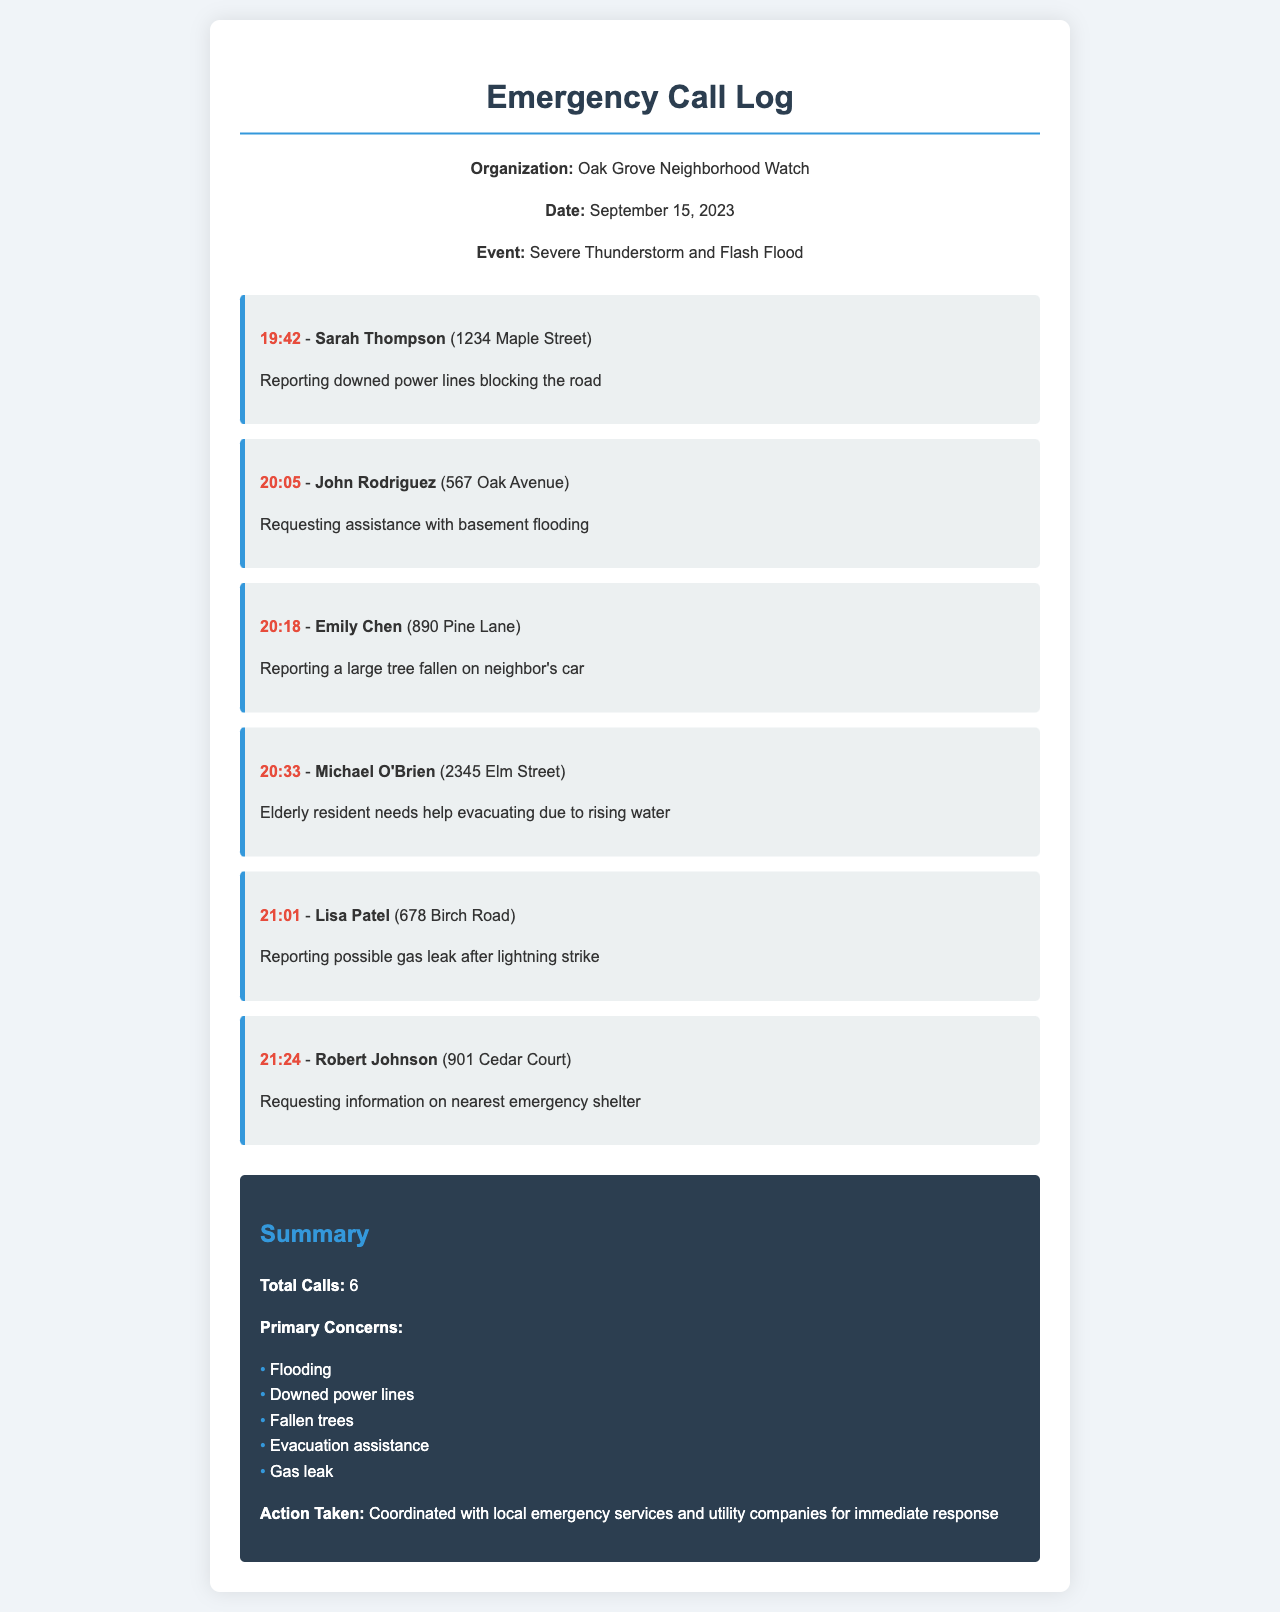What is the date of the event? The date of the event is explicitly stated in the document, which is September 15, 2023.
Answer: September 15, 2023 How many total calls were made? The total number of calls is provided in the summary section of the document, which lists the total calls as 6.
Answer: 6 Who reported the gas leak? The call log names Lisa Patel as the caller who reported a possible gas leak.
Answer: Lisa Patel What time did the first call occur? The time of the first call can be found in the call log, which lists it as 19:42.
Answer: 19:42 What was a primary concern during the storm? The summary section lists primary concerns, one of which is flooding.
Answer: Flooding Which caller requested evacuation assistance? The call log specifies that Michael O'Brien requested help evacuating due to rising water.
Answer: Michael O'Brien What is the address of the caller who reported downed power lines? The document specifies that Sarah Thompson, who lives at 1234 Maple Street, reported downed power lines.
Answer: 1234 Maple Street What type of event prompted the emergency calls? The event type is stated in the document as a Severe Thunderstorm and Flash Flood.
Answer: Severe Thunderstorm and Flash Flood What action was taken based on the calls? The summary indicates that coordination with local emergency services and utility companies was done for immediate response.
Answer: Coordinated with local emergency services and utility companies 